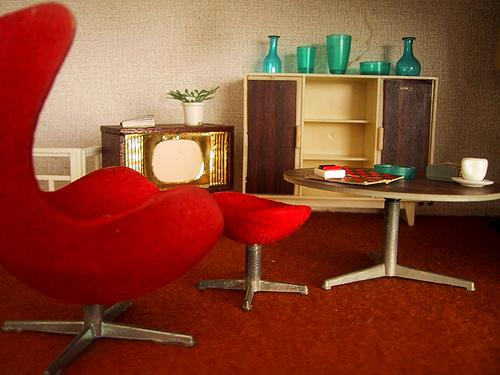This style of furniture was popular in what era? Please explain your reasoning. 20th century. This style was popular in the 1950s and known as mid-century modern. 